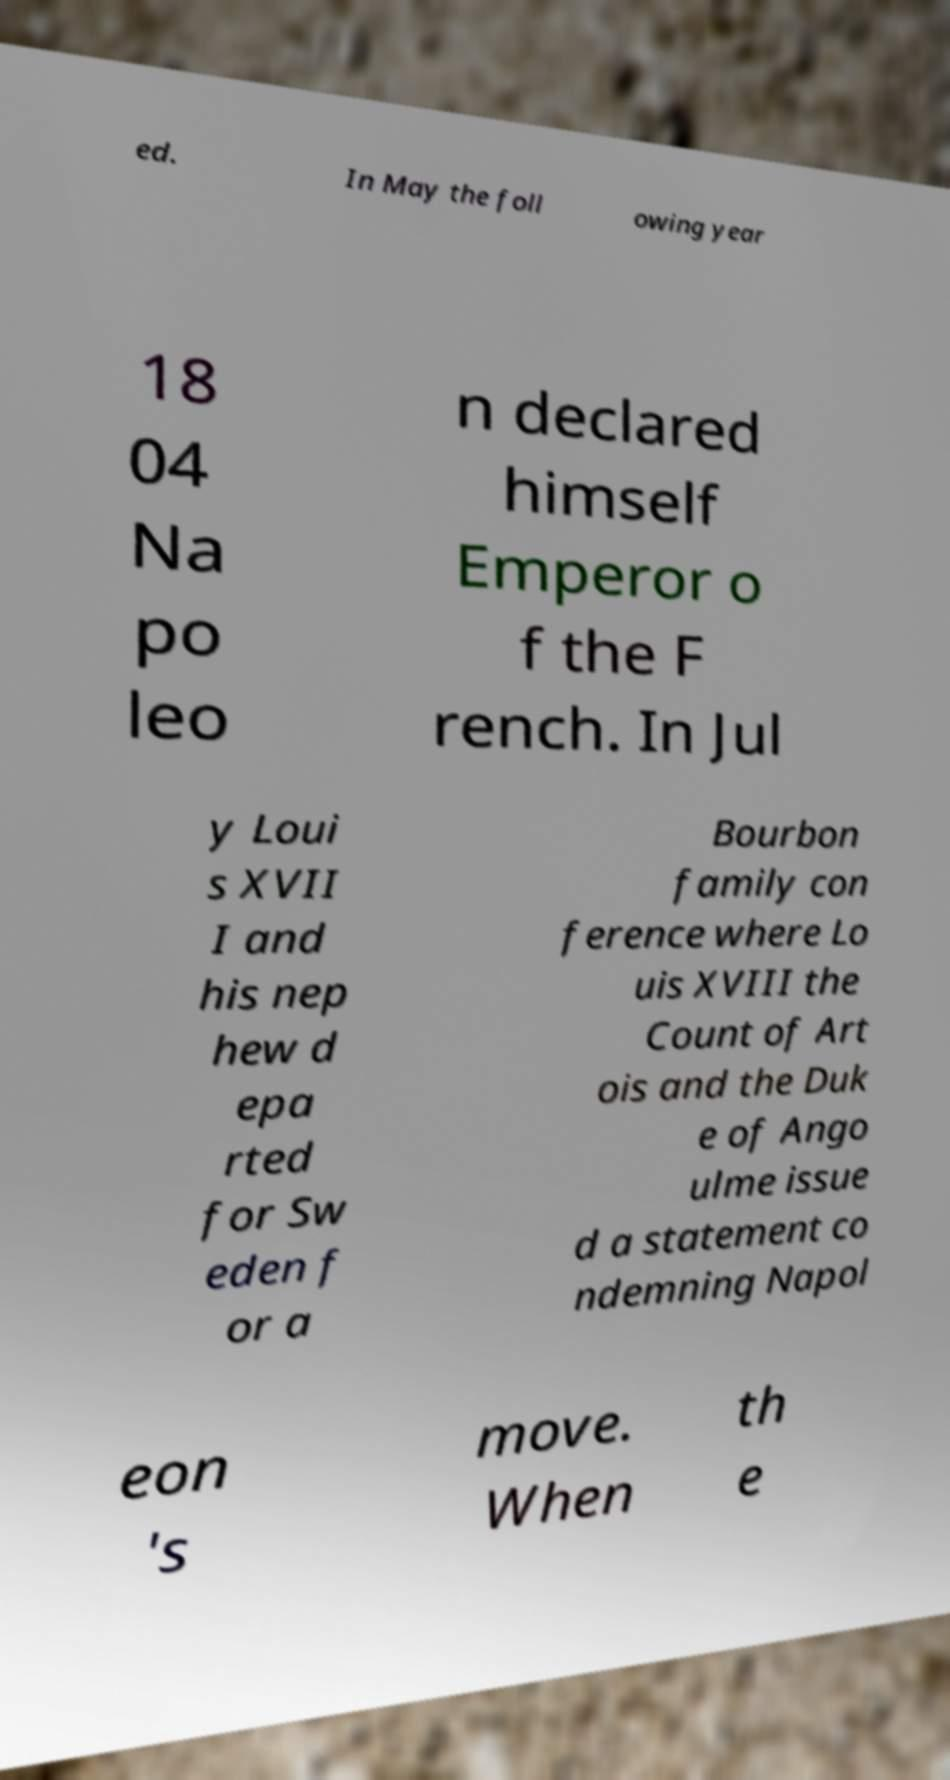What messages or text are displayed in this image? I need them in a readable, typed format. ed. In May the foll owing year 18 04 Na po leo n declared himself Emperor o f the F rench. In Jul y Loui s XVII I and his nep hew d epa rted for Sw eden f or a Bourbon family con ference where Lo uis XVIII the Count of Art ois and the Duk e of Ango ulme issue d a statement co ndemning Napol eon 's move. When th e 